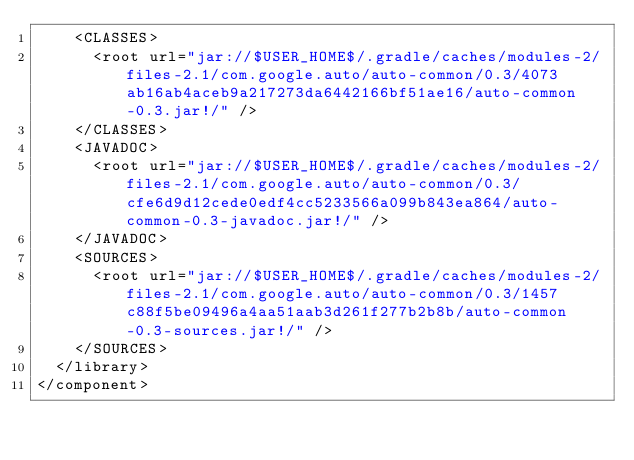Convert code to text. <code><loc_0><loc_0><loc_500><loc_500><_XML_>    <CLASSES>
      <root url="jar://$USER_HOME$/.gradle/caches/modules-2/files-2.1/com.google.auto/auto-common/0.3/4073ab16ab4aceb9a217273da6442166bf51ae16/auto-common-0.3.jar!/" />
    </CLASSES>
    <JAVADOC>
      <root url="jar://$USER_HOME$/.gradle/caches/modules-2/files-2.1/com.google.auto/auto-common/0.3/cfe6d9d12cede0edf4cc5233566a099b843ea864/auto-common-0.3-javadoc.jar!/" />
    </JAVADOC>
    <SOURCES>
      <root url="jar://$USER_HOME$/.gradle/caches/modules-2/files-2.1/com.google.auto/auto-common/0.3/1457c88f5be09496a4aa51aab3d261f277b2b8b/auto-common-0.3-sources.jar!/" />
    </SOURCES>
  </library>
</component></code> 